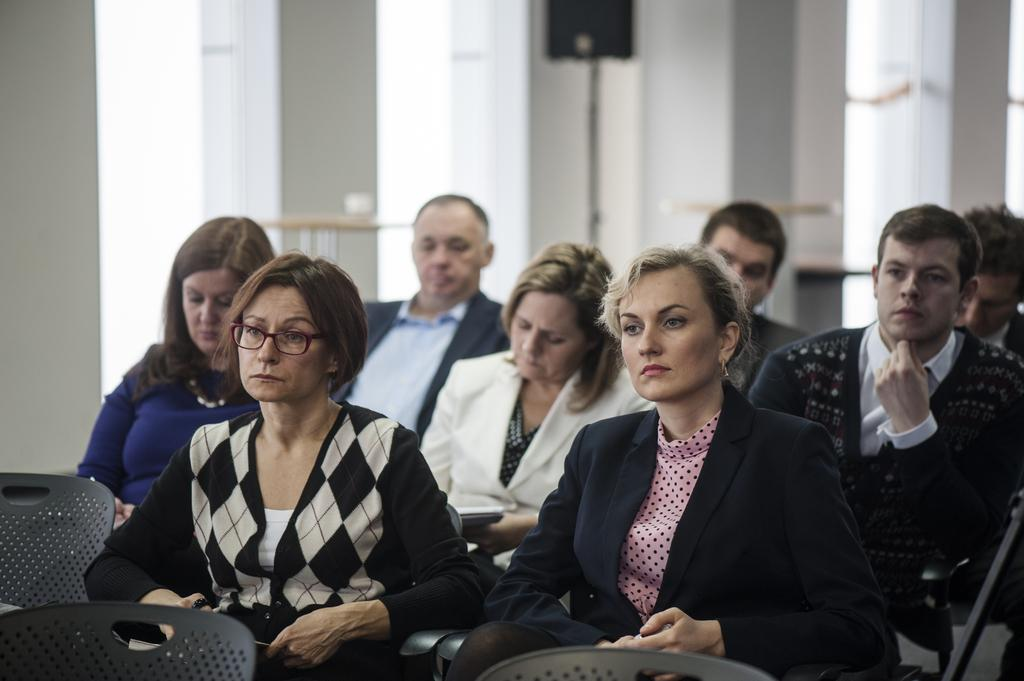What are the people in the image doing? The people in the image are sitting on chairs. How many chairs are visible in the image? There are both occupied and empty chairs in the image. What can be seen on the wall in the image? There is a speaker on the wall in the image. What architectural feature is present in the image? There are windows in the image. How would you describe the background of the image? The background of the image is blurred. What type of goat can be seen sitting on a chair in the image? There is no goat present in the image; it features people sitting on chairs. What direction is the lamp facing in the image? There is no lamp present in the image. 